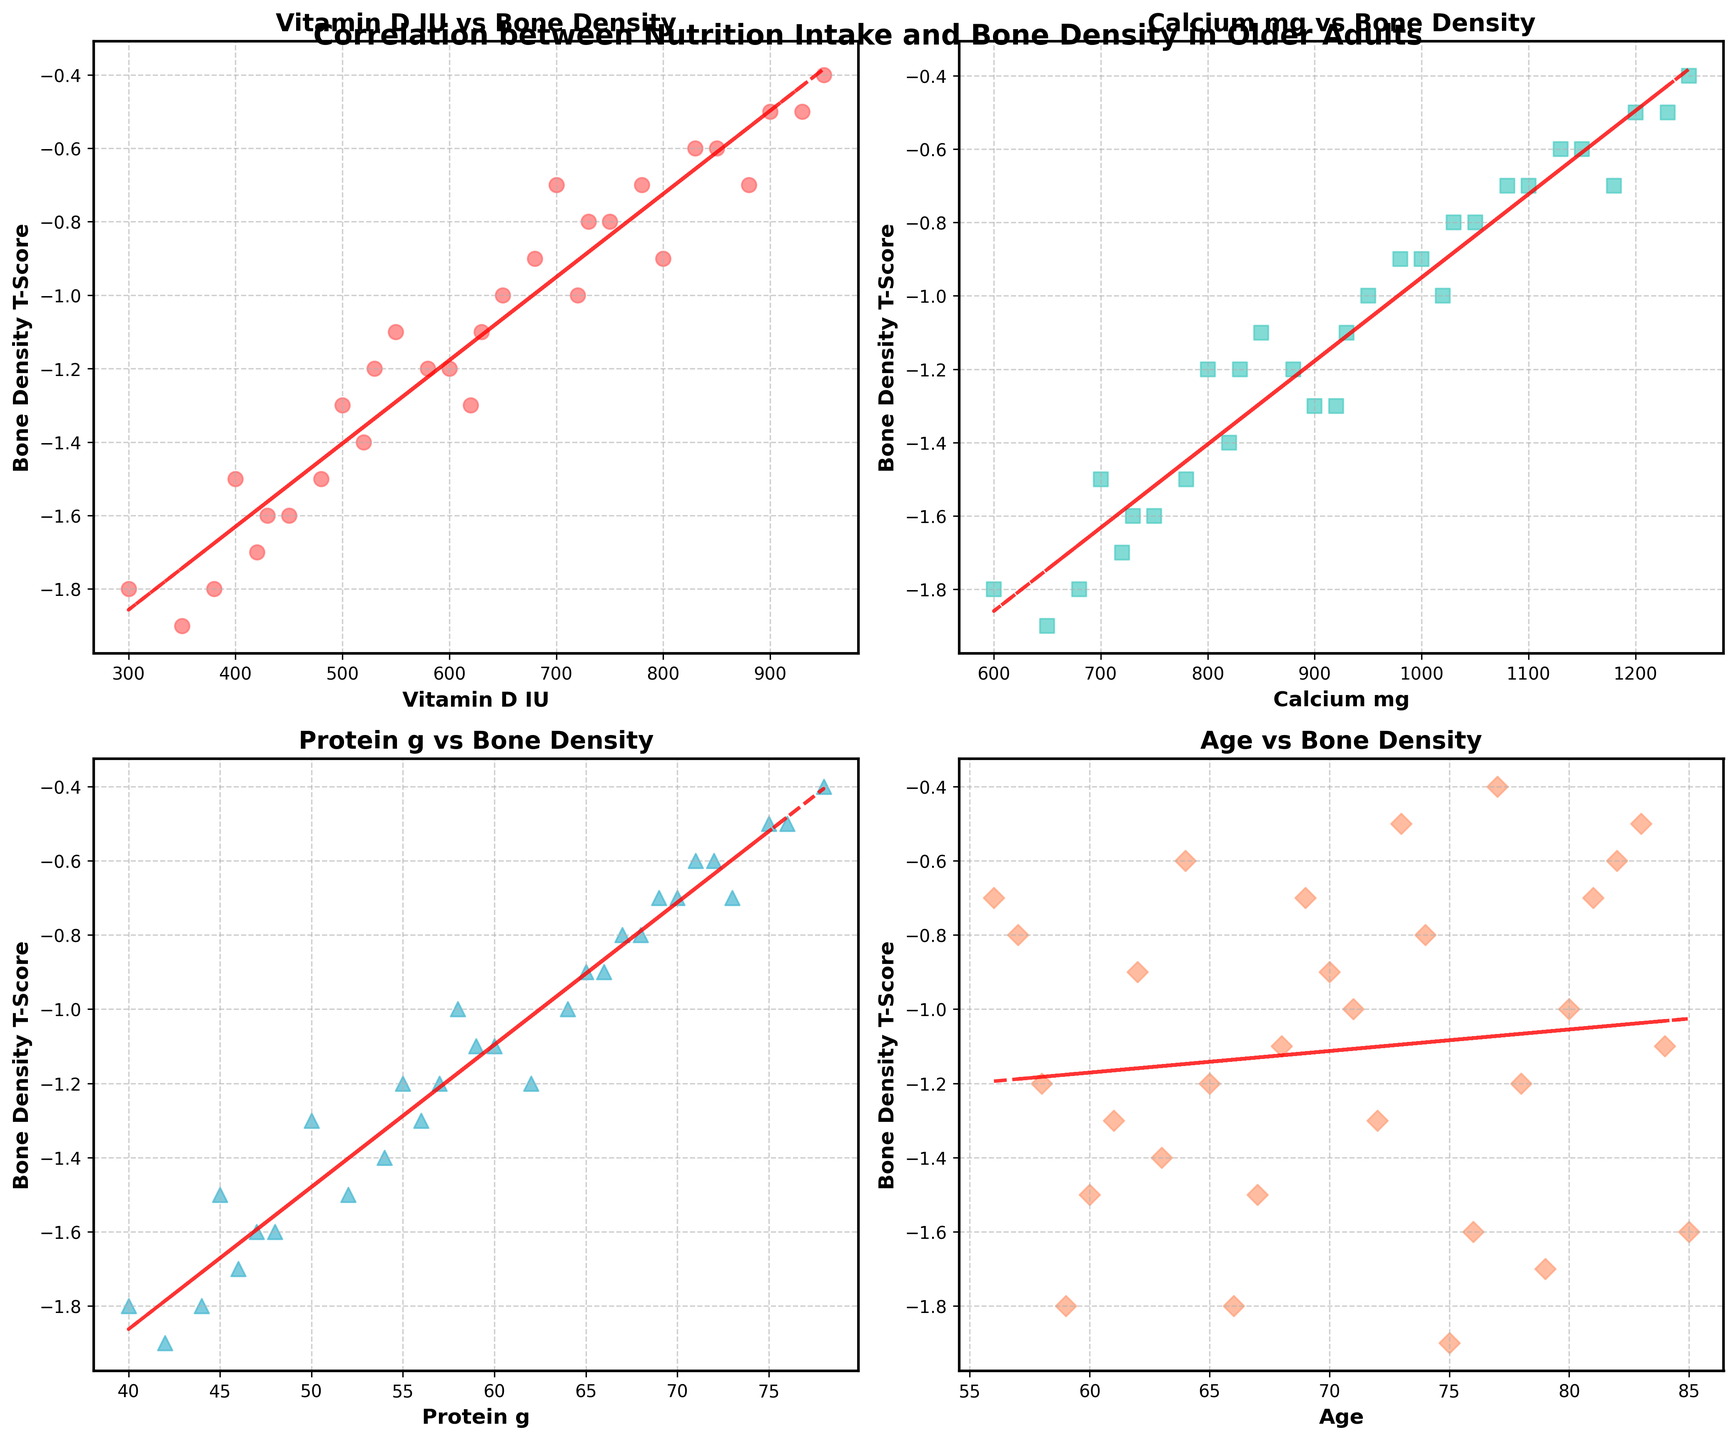What trend do you observe between Vitamin D intake and Bone Density T-Score? Observing the scatter plot for Vitamin D intake vs Bone Density T-Score, there appears to be a positive trend. As Vitamin D intake increases, Bone Density T-Score also tends to increase slightly. The trendline also indicates a positive slope.
Answer: Positive Trend Does higher Calcium intake correlate with better Bone Density T-Score? The scatter plot for Calcium intake vs Bone Density T-Score suggests a positive correlation. Higher Calcium intake generally corresponds to higher Bone Density T-Scores. The trendline confirms this positive relationship.
Answer: Yes Which nutrient shows a stronger visual positive correlation with Bone Density T-Score, Vitamin D or Protein? By comparing the scatter plots for Vitamin D and Protein against Bone Density T-Score, both show positive correlations, but the Protein intake vs T-Score plot appears to have a steeper positive trendline. Thus, Protein shows a stronger positive correlation visually.
Answer: Protein How does Bone Density T-Score vary with age? In the scatter plot for Age vs Bone Density T-Score, the trendline shows a negative slope, indicating that Bone Density T-Score tends to decrease with increasing age.
Answer: Decreases with Age Is there any participant with both high Calcium intake and high Bone Density T-Score? Yes, the participant with the highest Calcium intake (~1250 mg) has one of the highest Bone Density T-Scores (~-0.4), visible in the plot for Calcium intake vs Bone Density T-Score.
Answer: Yes What is the effect of Protein intake on Bone Density T-Score? Observing the Protein intake vs Bone Density T-Score plot, there is a positive relationship. The scatter points and the trendline indicate that as Protein intake increases, Bone Density T-Score tends to increase.
Answer: Positive Effect Which age group exhibits the best Bone Density T-Scores? Based on the Age vs Bone Density T-Score plot, the scatter points show that younger adults in their early 60s and mid-70s tend to have better (less negative) Bone Density T-Scores compared to older adults in their late 70s and early 80s.
Answer: Early 60s and Mid-70s Do all plots show a linear trend? Yes, each subplot for Vitamin D, Calcium, Protein, and Age vs Bone Density T-Score includes a trendline. All these trendlines appear straight, indicating an assumed linear relationship in each case.
Answer: Yes 